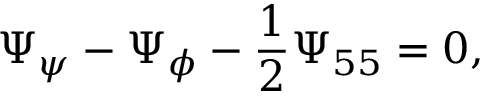<formula> <loc_0><loc_0><loc_500><loc_500>\Psi _ { \psi } - \Psi _ { \phi } - \frac { 1 } { 2 } \Psi _ { 5 5 } = 0 ,</formula> 